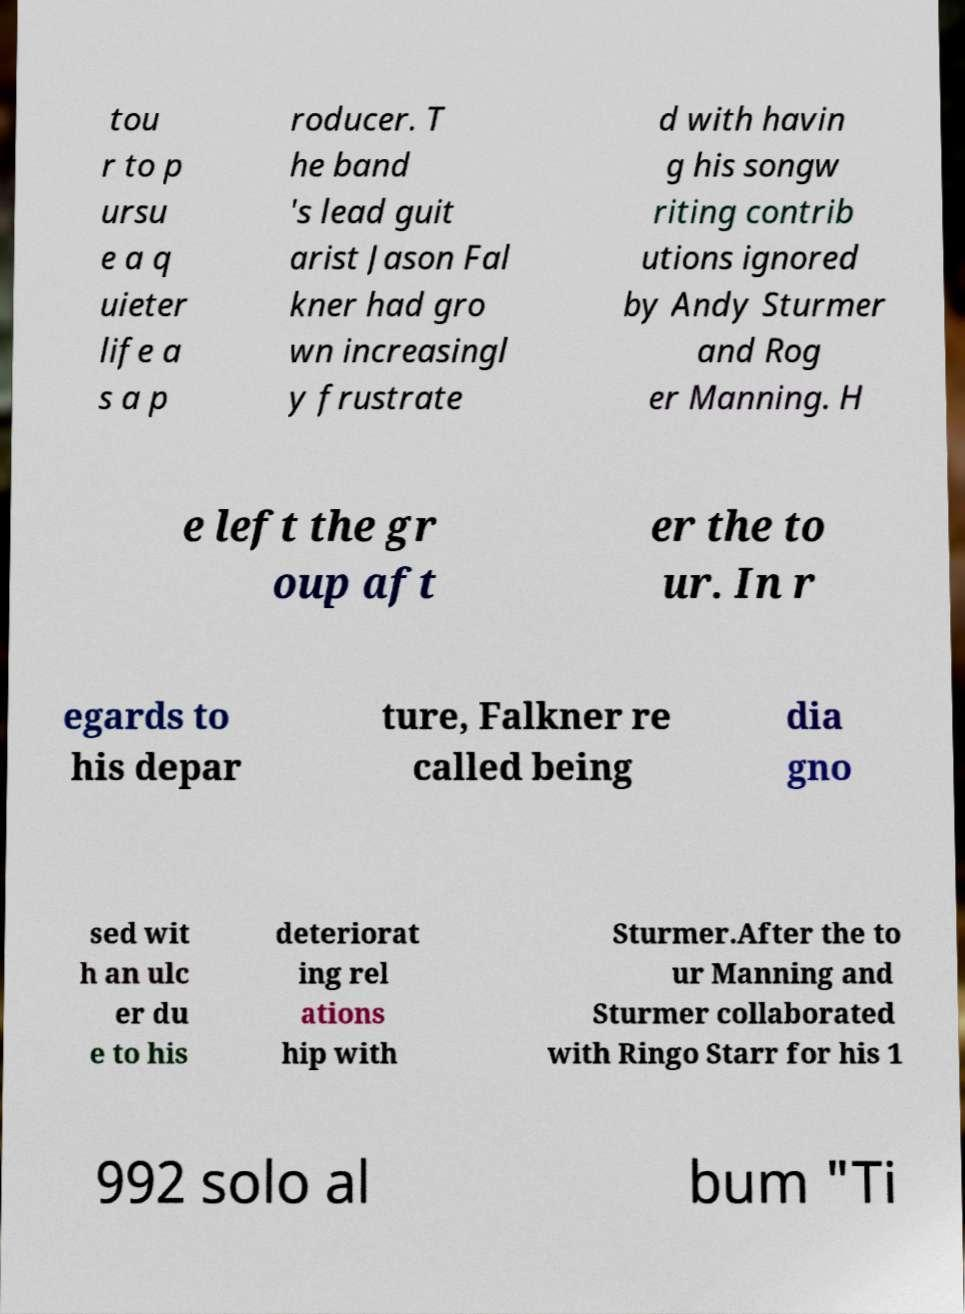Please read and relay the text visible in this image. What does it say? tou r to p ursu e a q uieter life a s a p roducer. T he band 's lead guit arist Jason Fal kner had gro wn increasingl y frustrate d with havin g his songw riting contrib utions ignored by Andy Sturmer and Rog er Manning. H e left the gr oup aft er the to ur. In r egards to his depar ture, Falkner re called being dia gno sed wit h an ulc er du e to his deteriorat ing rel ations hip with Sturmer.After the to ur Manning and Sturmer collaborated with Ringo Starr for his 1 992 solo al bum "Ti 